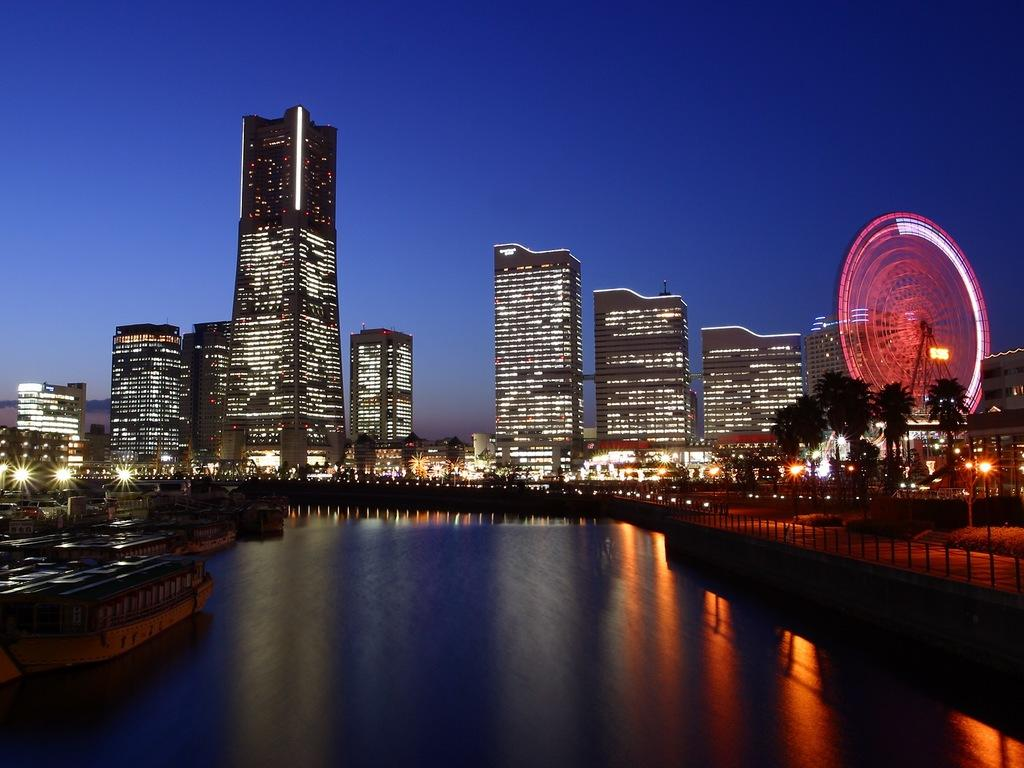What type of structures can be seen in the background of the image? There are buildings in the background of the image. How are the buildings illuminated in the image? The buildings have lights all over them. What is visible above the buildings in the image? The sky is visible above the buildings. What natural feature is present in the front of the image? There is a lake in the front of the image. Can you tell me how many coaches are parked near the lake in the image? There is no coach present in the image; it features a lake and illuminated buildings in the background. What type of plot is being developed around the lake in the image? There is no plot development visible in the image; it is a static scene featuring a lake and buildings. 